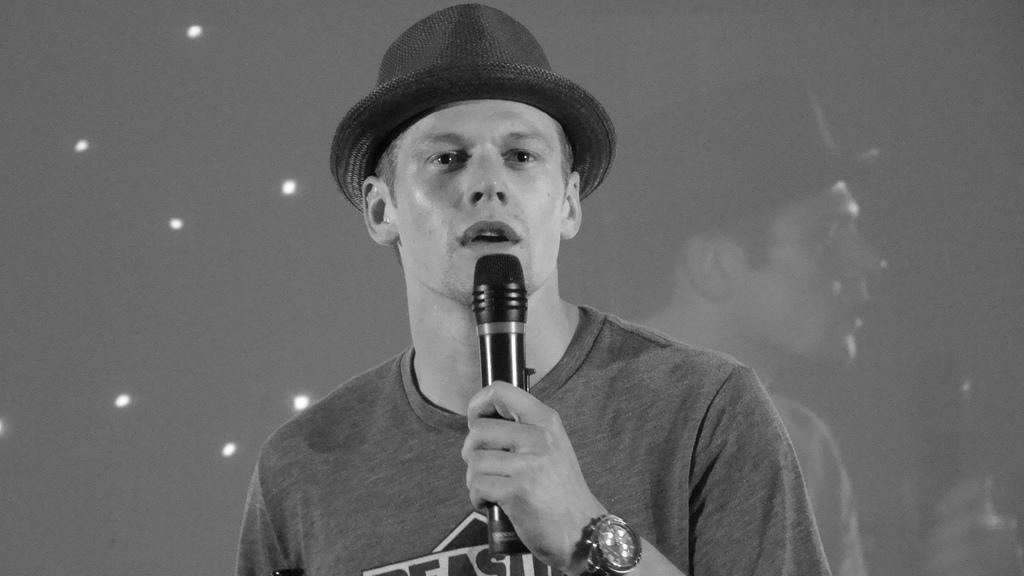Describe this image in one or two sentences. The man wore t-shirt, cap and holding mic. 